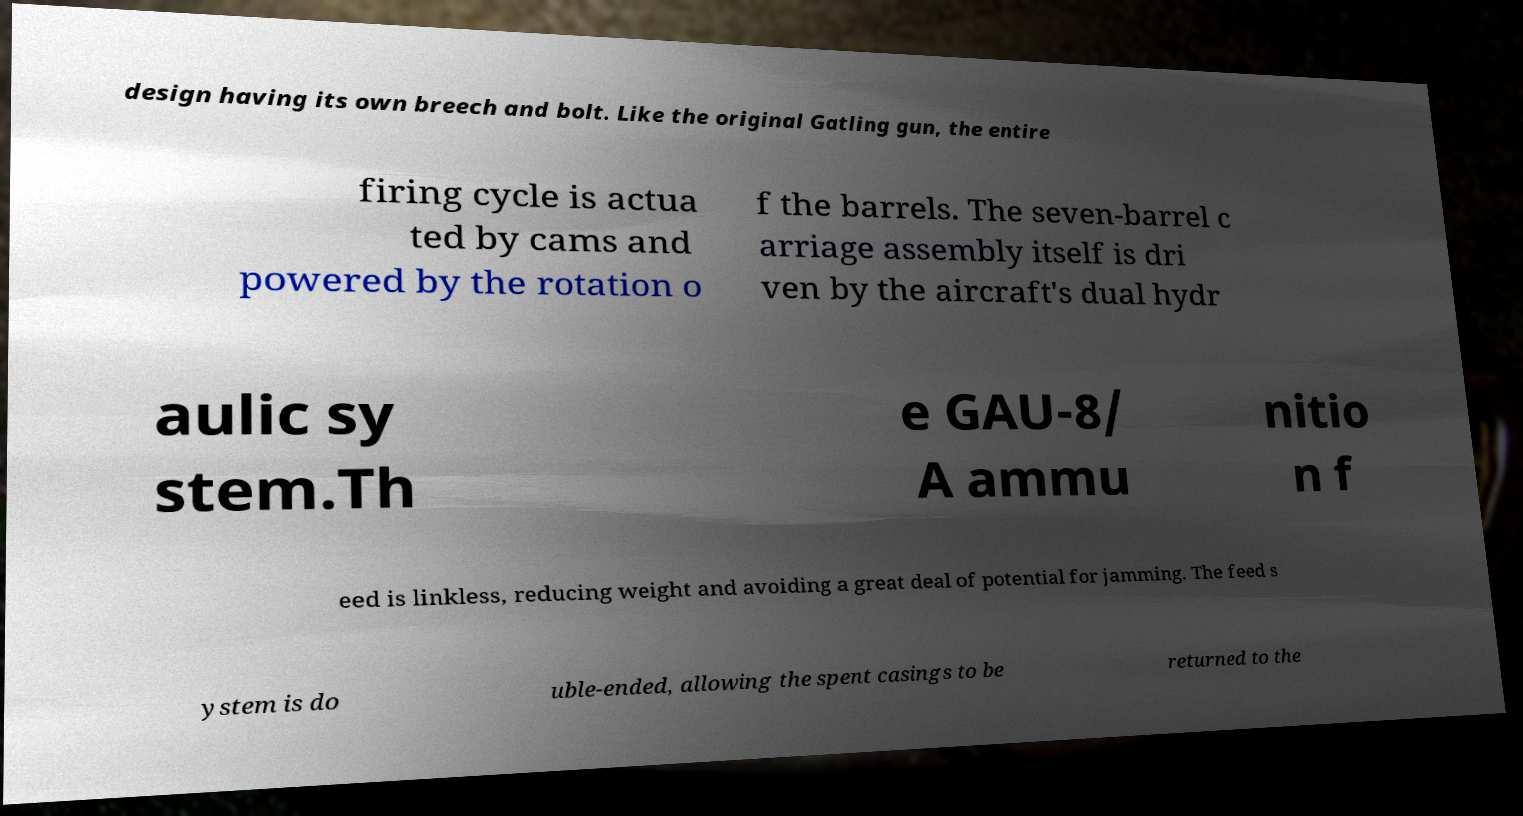Could you extract and type out the text from this image? design having its own breech and bolt. Like the original Gatling gun, the entire firing cycle is actua ted by cams and powered by the rotation o f the barrels. The seven-barrel c arriage assembly itself is dri ven by the aircraft's dual hydr aulic sy stem.Th e GAU-8/ A ammu nitio n f eed is linkless, reducing weight and avoiding a great deal of potential for jamming. The feed s ystem is do uble-ended, allowing the spent casings to be returned to the 